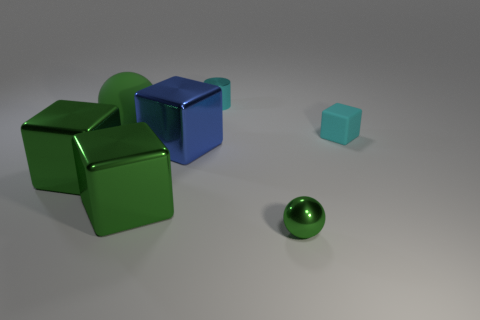Subtract all cyan cubes. How many cubes are left? 3 Subtract all cyan spheres. How many green blocks are left? 2 Add 1 cyan metallic cylinders. How many objects exist? 8 Subtract all green cubes. How many cubes are left? 2 Subtract 2 cubes. How many cubes are left? 2 Subtract all spheres. How many objects are left? 5 Subtract all large red objects. Subtract all blue metallic objects. How many objects are left? 6 Add 1 small matte objects. How many small matte objects are left? 2 Add 1 small cyan cubes. How many small cyan cubes exist? 2 Subtract 0 gray cylinders. How many objects are left? 7 